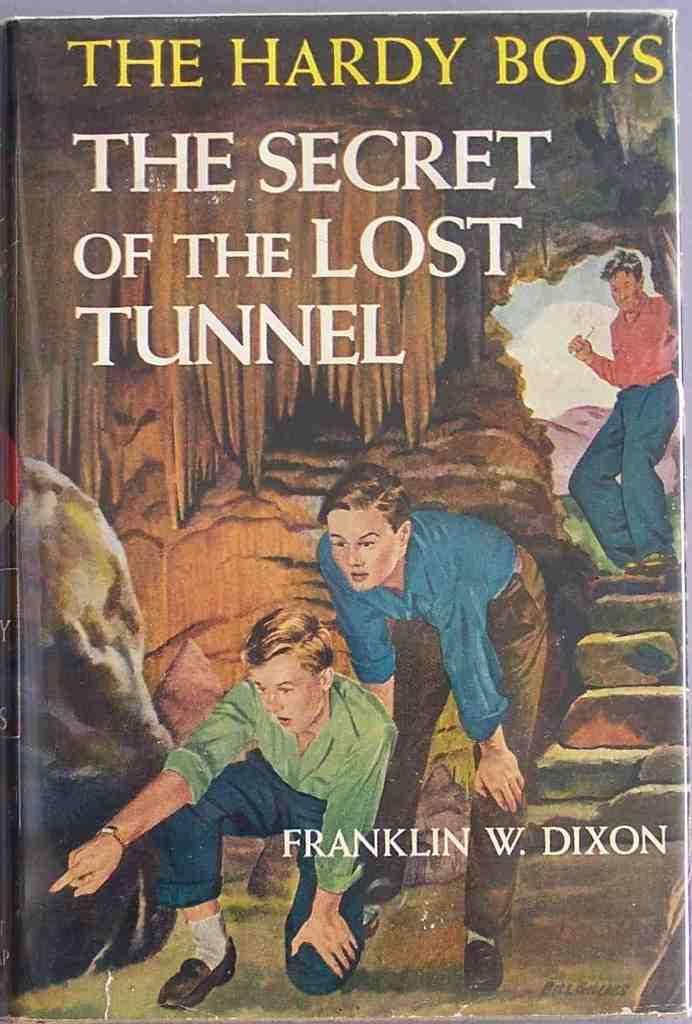<image>
Summarize the visual content of the image. A novel entitled The Hardy Boys, The Secret of the Lost Tunnel written by Franklin W. Dixon. 